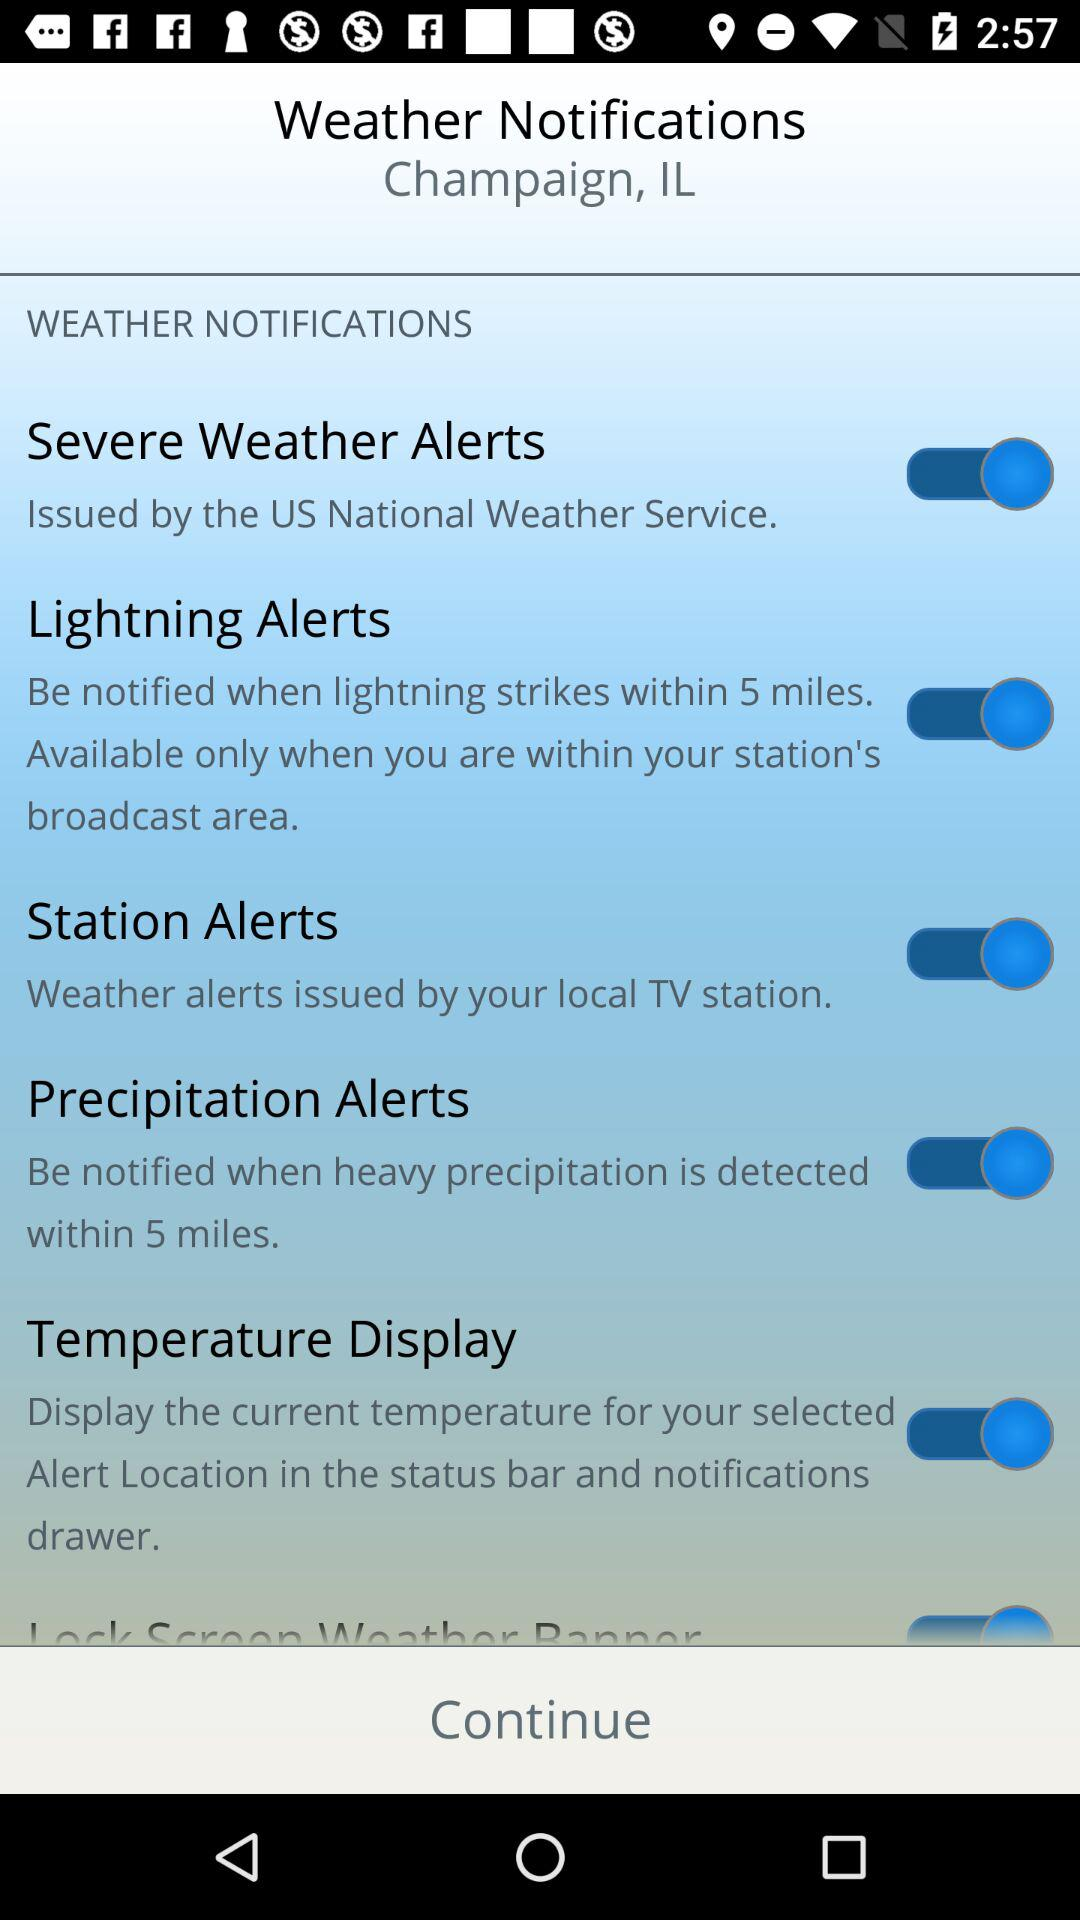What is the status of "Lightning Alerts"? The status is "on". 